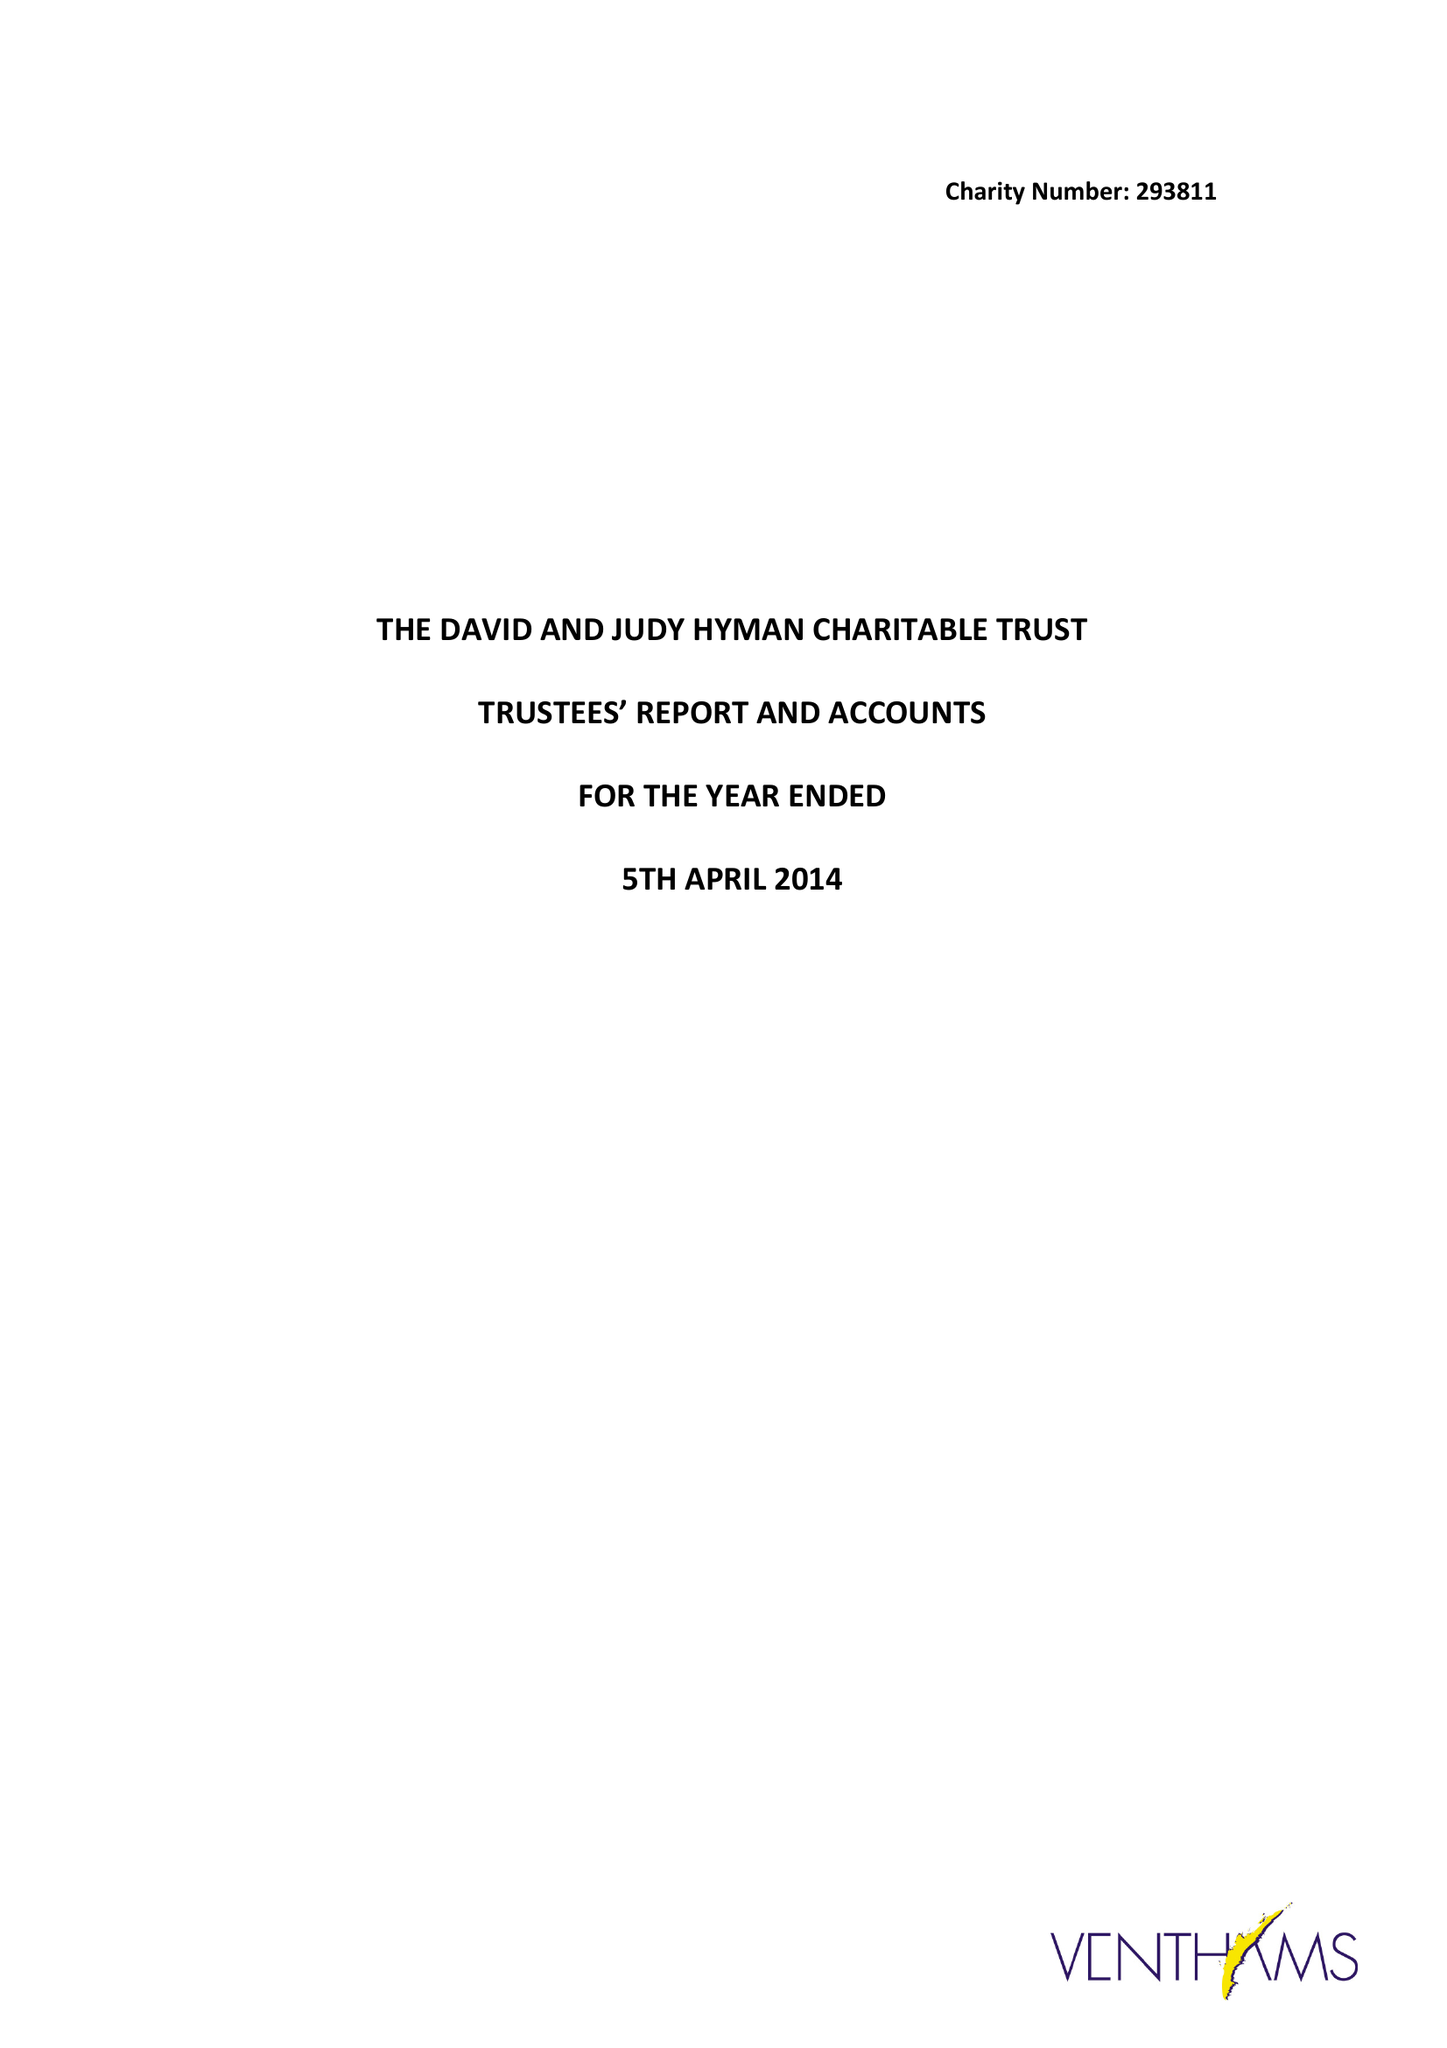What is the value for the charity_number?
Answer the question using a single word or phrase. 293811 